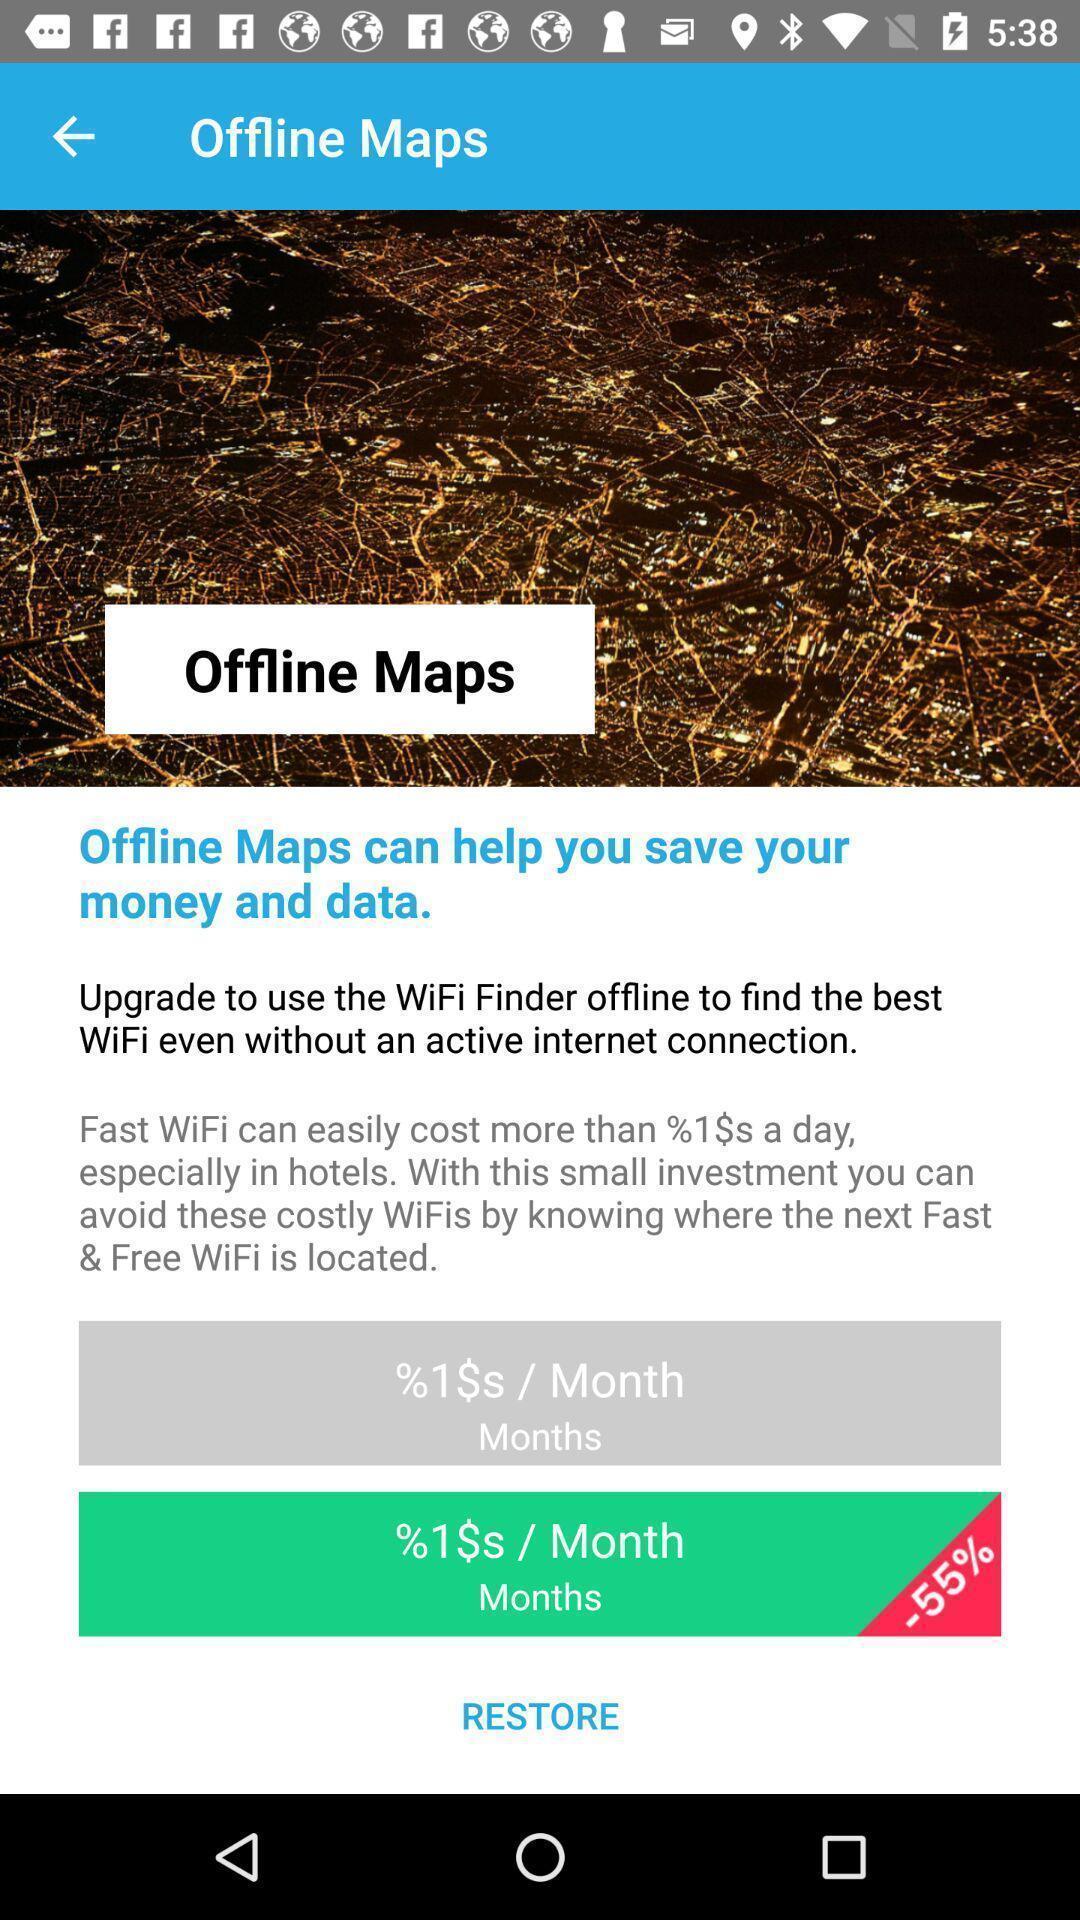Please provide a description for this image. Screen displaying the offline maps page. 